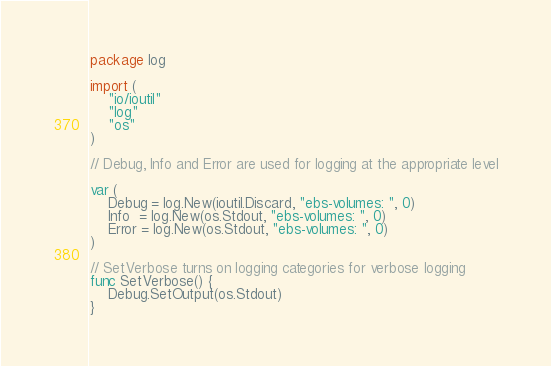<code> <loc_0><loc_0><loc_500><loc_500><_Go_>package log

import (
	"io/ioutil"
	"log"
	"os"
)

// Debug, Info and Error are used for logging at the appropriate level

var (
	Debug = log.New(ioutil.Discard, "ebs-volumes: ", 0)
	Info  = log.New(os.Stdout, "ebs-volumes: ", 0)
	Error = log.New(os.Stdout, "ebs-volumes: ", 0)
)

// SetVerbose turns on logging categories for verbose logging
func SetVerbose() {
	Debug.SetOutput(os.Stdout)
}
</code> 